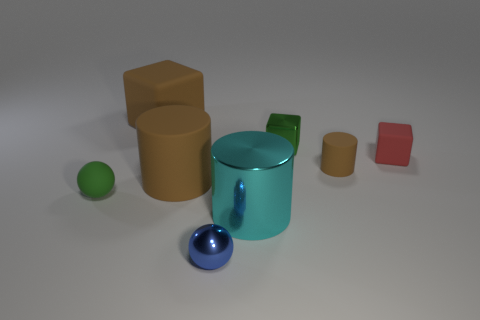Add 1 blue spheres. How many objects exist? 9 Subtract all cubes. How many objects are left? 5 Add 7 small red rubber things. How many small red rubber things exist? 8 Subtract 0 yellow cylinders. How many objects are left? 8 Subtract all large metallic cylinders. Subtract all red things. How many objects are left? 6 Add 6 brown cylinders. How many brown cylinders are left? 8 